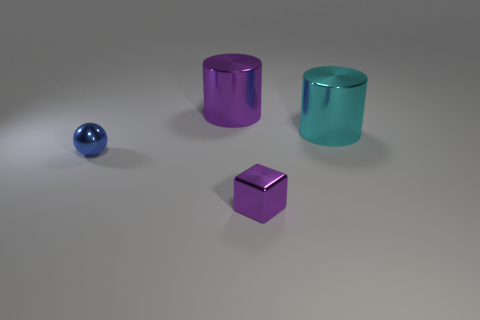There is a purple shiny thing that is on the left side of the purple shiny thing in front of the large object that is to the left of the tiny cube; what is its size?
Provide a short and direct response. Large. There is a shiny thing that is to the right of the purple metallic cylinder and left of the big cyan cylinder; what is its size?
Provide a short and direct response. Small. There is a big metallic object left of the metallic object on the right side of the cube; what shape is it?
Your response must be concise. Cylinder. Are there any other things that are the same color as the block?
Ensure brevity in your answer.  Yes. There is a big shiny thing that is right of the purple metallic cylinder; what shape is it?
Make the answer very short. Cylinder. There is a thing that is on the right side of the blue metal object and in front of the cyan cylinder; what is its shape?
Provide a short and direct response. Cube. What number of purple things are either tiny metal balls or metal things?
Ensure brevity in your answer.  2. Does the big shiny thing in front of the big purple metallic cylinder have the same color as the metallic ball?
Your answer should be very brief. No. What size is the cylinder that is on the left side of the purple metallic object in front of the blue metallic sphere?
Your answer should be very brief. Large. What is the material of the purple object that is the same size as the metal sphere?
Give a very brief answer. Metal. 